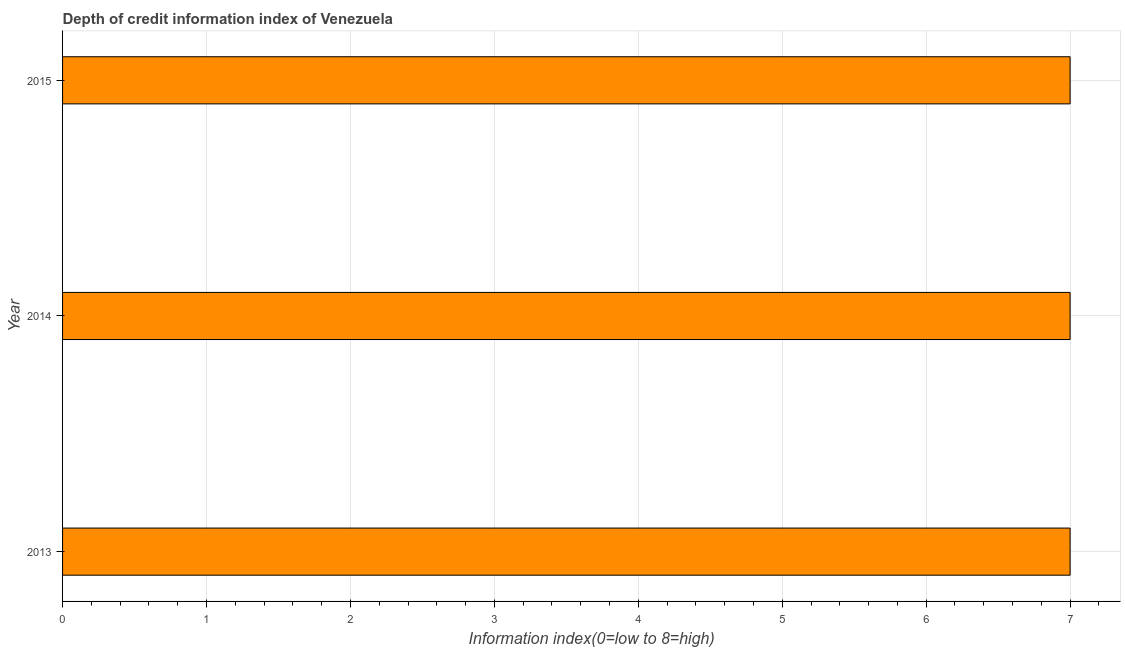Does the graph contain any zero values?
Make the answer very short. No. Does the graph contain grids?
Offer a terse response. Yes. What is the title of the graph?
Keep it short and to the point. Depth of credit information index of Venezuela. What is the label or title of the X-axis?
Make the answer very short. Information index(0=low to 8=high). What is the label or title of the Y-axis?
Ensure brevity in your answer.  Year. What is the depth of credit information index in 2013?
Your answer should be compact. 7. Across all years, what is the minimum depth of credit information index?
Your answer should be very brief. 7. In which year was the depth of credit information index minimum?
Offer a very short reply. 2013. What is the sum of the depth of credit information index?
Offer a very short reply. 21. What is the difference between the depth of credit information index in 2014 and 2015?
Ensure brevity in your answer.  0. What is the average depth of credit information index per year?
Provide a short and direct response. 7. What is the median depth of credit information index?
Your answer should be compact. 7. What is the ratio of the depth of credit information index in 2013 to that in 2014?
Provide a short and direct response. 1. Is the depth of credit information index in 2013 less than that in 2014?
Give a very brief answer. No. Is the sum of the depth of credit information index in 2013 and 2014 greater than the maximum depth of credit information index across all years?
Your response must be concise. Yes. What is the difference between the highest and the lowest depth of credit information index?
Your response must be concise. 0. In how many years, is the depth of credit information index greater than the average depth of credit information index taken over all years?
Make the answer very short. 0. How many years are there in the graph?
Give a very brief answer. 3. What is the Information index(0=low to 8=high) of 2013?
Provide a succinct answer. 7. What is the Information index(0=low to 8=high) in 2014?
Provide a short and direct response. 7. What is the Information index(0=low to 8=high) in 2015?
Keep it short and to the point. 7. What is the difference between the Information index(0=low to 8=high) in 2014 and 2015?
Make the answer very short. 0. What is the ratio of the Information index(0=low to 8=high) in 2013 to that in 2014?
Offer a terse response. 1. What is the ratio of the Information index(0=low to 8=high) in 2014 to that in 2015?
Provide a short and direct response. 1. 